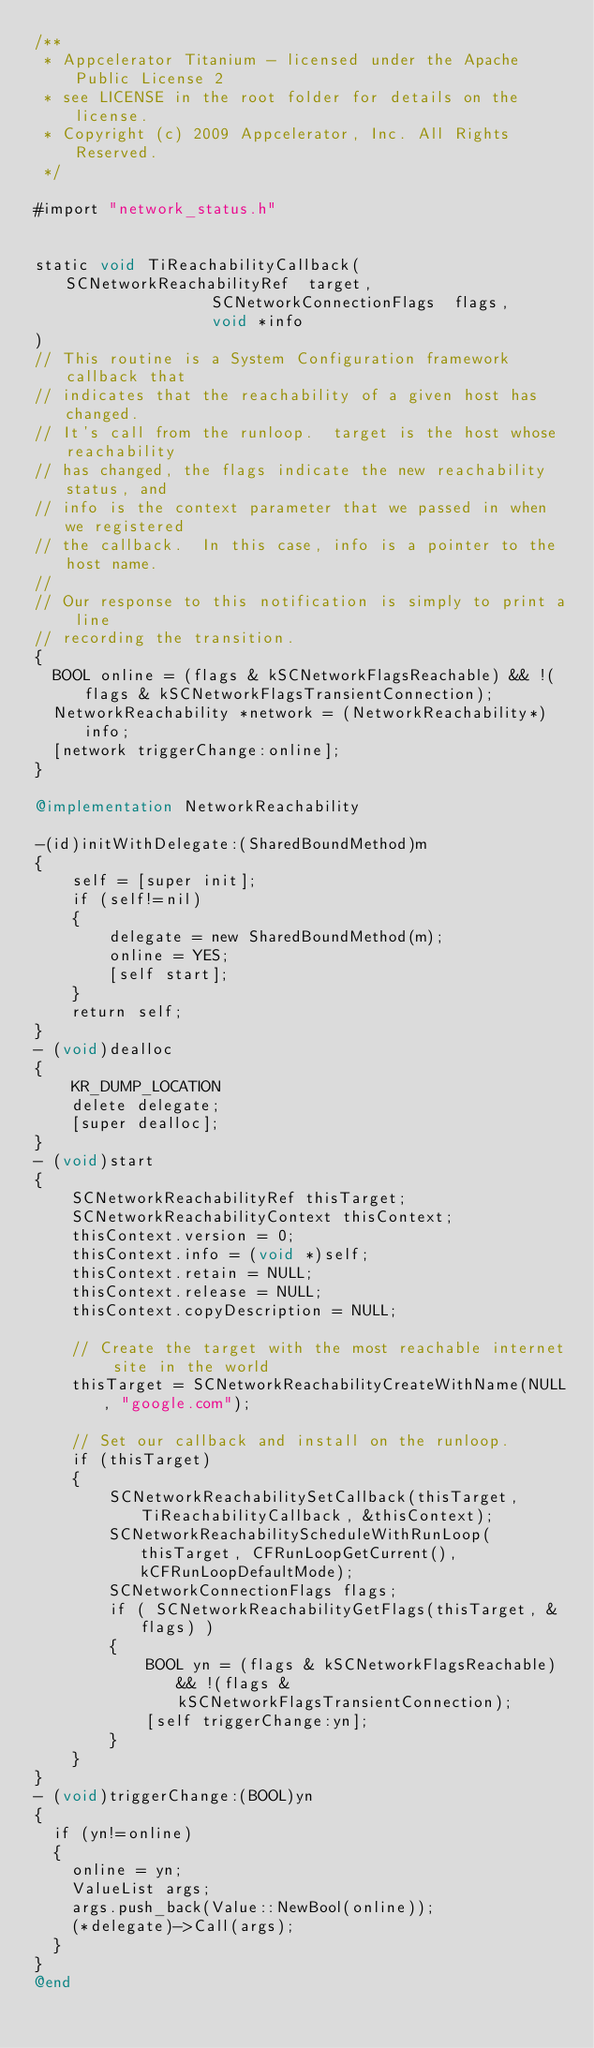Convert code to text. <code><loc_0><loc_0><loc_500><loc_500><_ObjectiveC_>/**
 * Appcelerator Titanium - licensed under the Apache Public License 2
 * see LICENSE in the root folder for details on the license.
 * Copyright (c) 2009 Appcelerator, Inc. All Rights Reserved.
 */

#import "network_status.h"
 

static void TiReachabilityCallback(SCNetworkReachabilityRef  target,
                   SCNetworkConnectionFlags  flags,
                   void *info
)
// This routine is a System Configuration framework callback that 
// indicates that the reachability of a given host has changed.  
// It's call from the runloop.  target is the host whose reachability 
// has changed, the flags indicate the new reachability status, and 
// info is the context parameter that we passed in when we registered 
// the callback.  In this case, info is a pointer to the host name.
// 
// Our response to this notification is simply to print a line 
// recording the transition.
{
  BOOL online = (flags & kSCNetworkFlagsReachable) && !(flags & kSCNetworkFlagsTransientConnection);
  NetworkReachability *network = (NetworkReachability*)info;
  [network triggerChange:online];
}

@implementation NetworkReachability

-(id)initWithDelegate:(SharedBoundMethod)m
{
	self = [super init];
	if (self!=nil)
	{	
		delegate = new SharedBoundMethod(m);
		online = YES;
		[self start];
	}
	return self;
}
- (void)dealloc
{
	KR_DUMP_LOCATION
	delete delegate;
	[super dealloc];
}
- (void)start
{
	SCNetworkReachabilityRef thisTarget;
	SCNetworkReachabilityContext thisContext;
    thisContext.version = 0;
    thisContext.info = (void *)self;
    thisContext.retain = NULL;
    thisContext.release = NULL;
    thisContext.copyDescription = NULL;

    // Create the target with the most reachable internet site in the world
    thisTarget = SCNetworkReachabilityCreateWithName(NULL, "google.com");

    // Set our callback and install on the runloop.
    if (thisTarget) 
    {
    	SCNetworkReachabilitySetCallback(thisTarget, TiReachabilityCallback, &thisContext);
    	SCNetworkReachabilityScheduleWithRunLoop(thisTarget, CFRunLoopGetCurrent(), kCFRunLoopDefaultMode);
      	SCNetworkConnectionFlags flags;
      	if ( SCNetworkReachabilityGetFlags(thisTarget, &flags) ) 
      	{
        	BOOL yn = (flags & kSCNetworkFlagsReachable) && !(flags & kSCNetworkFlagsTransientConnection);
        	[self triggerChange:yn];
      	}
    }
}
- (void)triggerChange:(BOOL)yn
{
  if (yn!=online)
  {
    online = yn;
	ValueList args;
	args.push_back(Value::NewBool(online));
	(*delegate)->Call(args);
  }
}
@end
</code> 